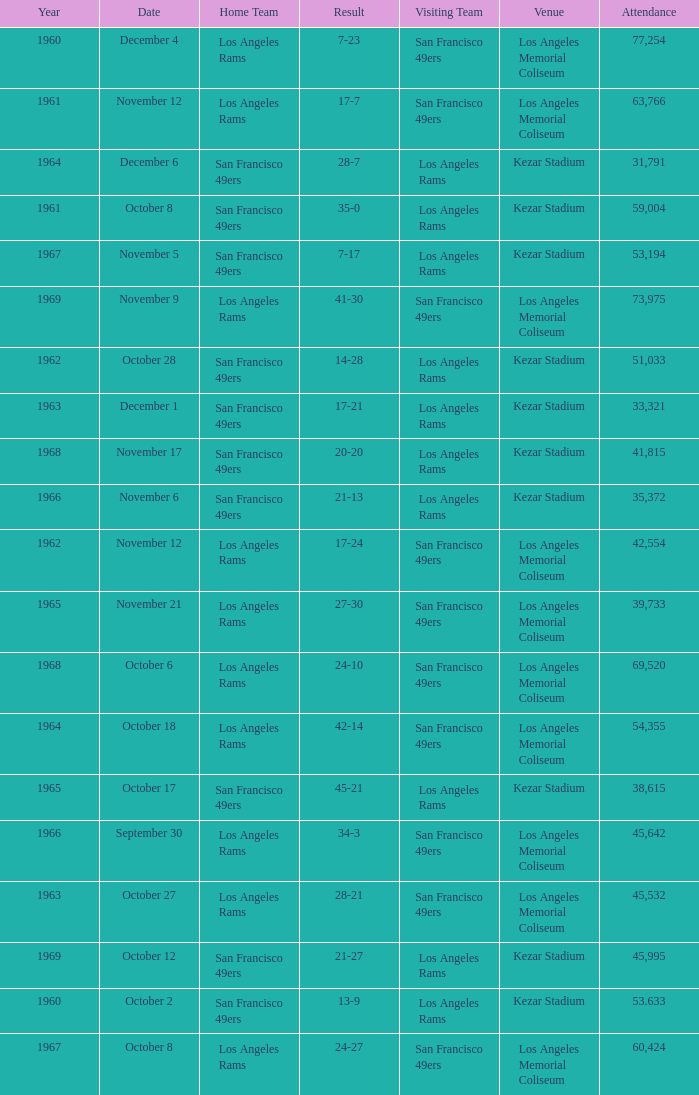What was the total attendance for a result of 7-23 before 1960? None. 